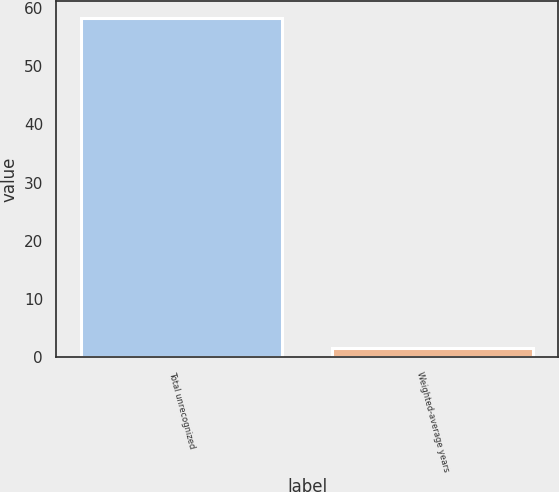Convert chart to OTSL. <chart><loc_0><loc_0><loc_500><loc_500><bar_chart><fcel>Total unrecognized<fcel>Weighted-average years<nl><fcel>58.3<fcel>1.7<nl></chart> 